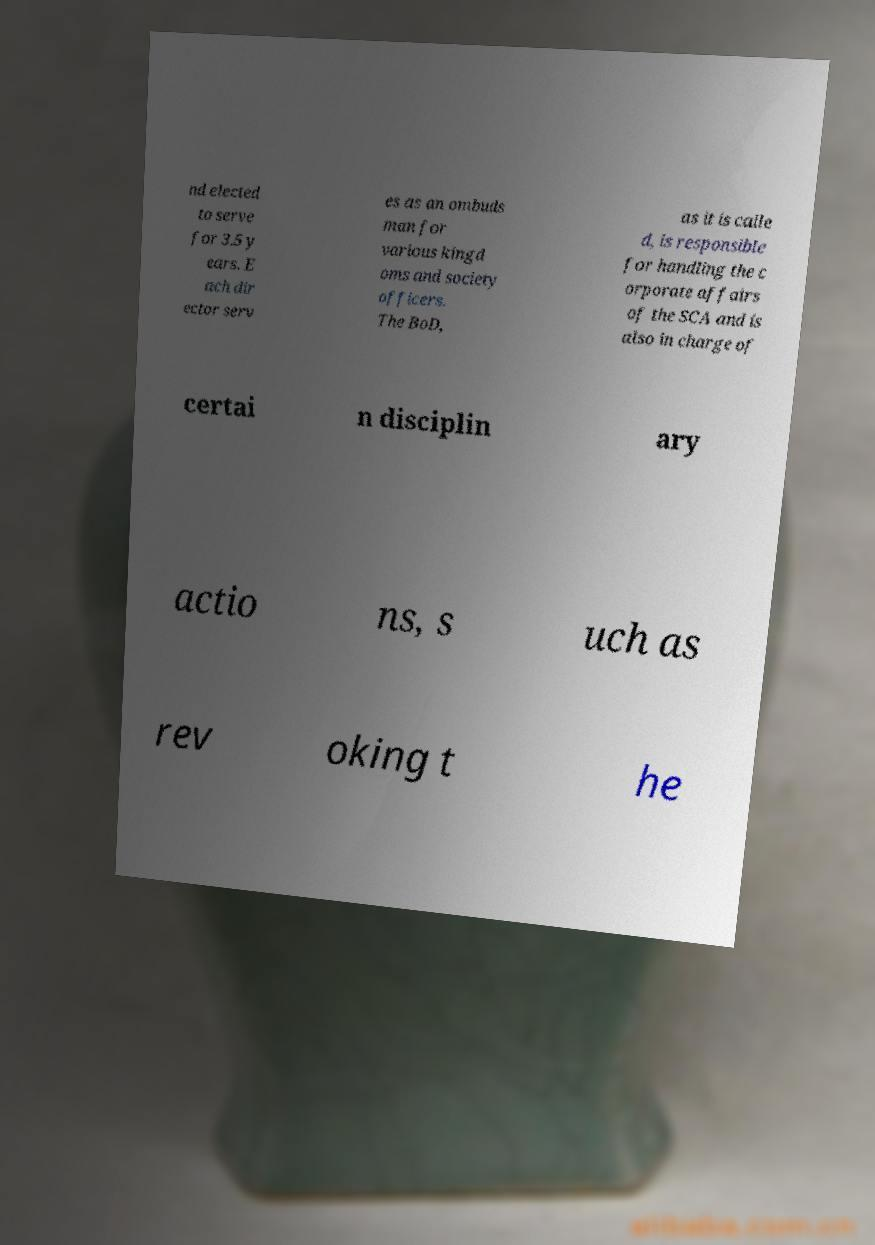Please read and relay the text visible in this image. What does it say? nd elected to serve for 3.5 y ears. E ach dir ector serv es as an ombuds man for various kingd oms and society officers. The BoD, as it is calle d, is responsible for handling the c orporate affairs of the SCA and is also in charge of certai n disciplin ary actio ns, s uch as rev oking t he 